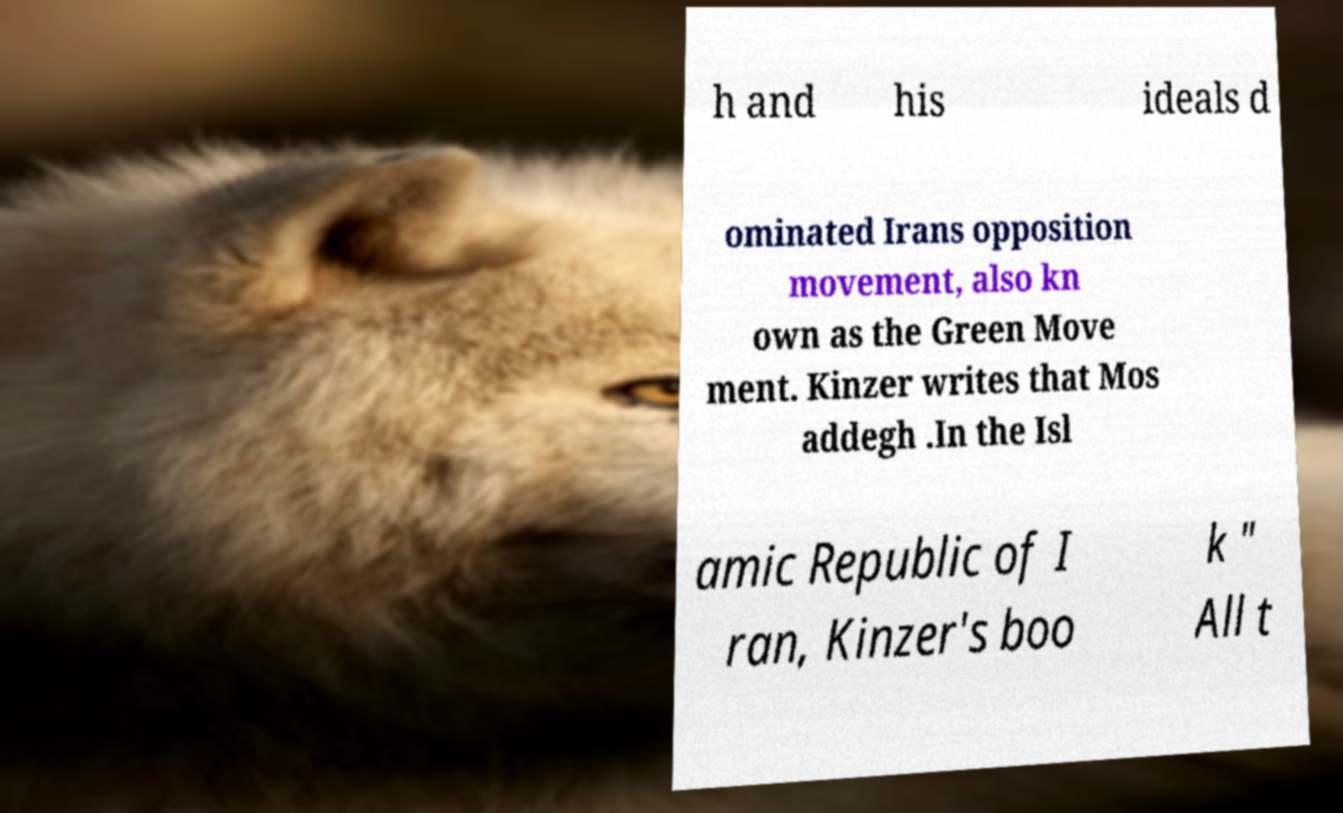Please identify and transcribe the text found in this image. h and his ideals d ominated Irans opposition movement, also kn own as the Green Move ment. Kinzer writes that Mos addegh .In the Isl amic Republic of I ran, Kinzer's boo k " All t 